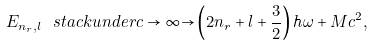Convert formula to latex. <formula><loc_0><loc_0><loc_500><loc_500>E _ { n _ { r } , l } \ s t a c k u n d e r { c \rightarrow \infty } { \rightarrow } \left ( 2 n _ { r } + l + \frac { 3 } { 2 } \right ) \hbar { \omega } + M c ^ { 2 } ,</formula> 